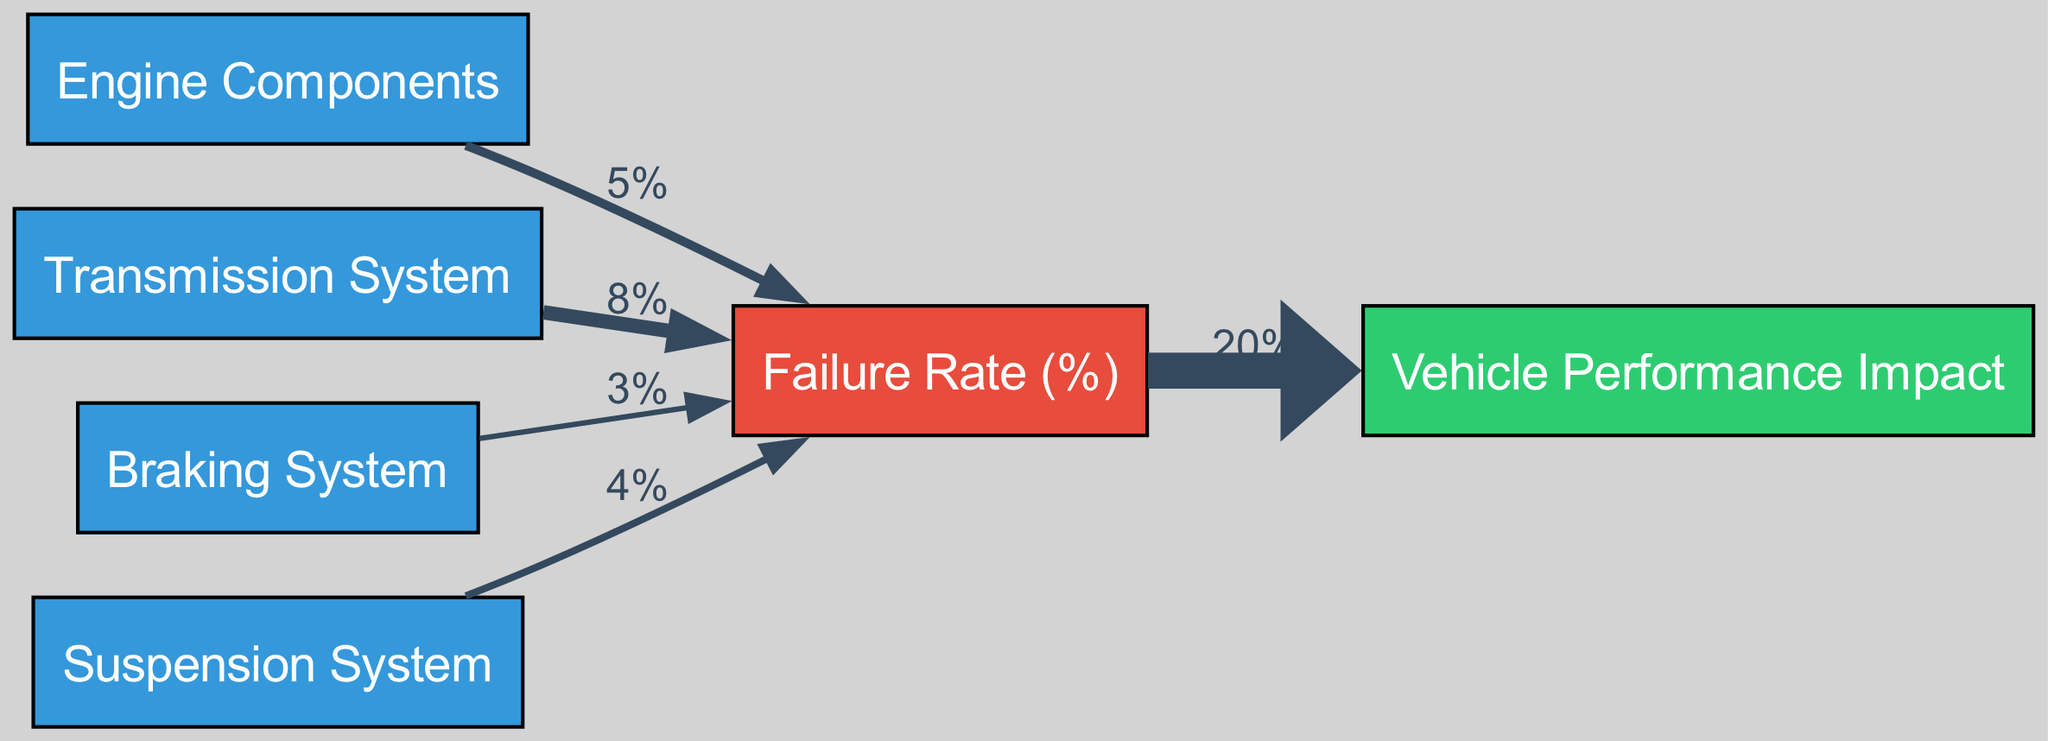What is the failure rate for Engine Components? By looking at the link between the "Engine Components" node and the "Failure Rate (%)" node, it shows a value of 5%.
Answer: 5% What is the failure rate for the Transmission System? The link connecting the "Transmission System" to "Failure Rate (%)" indicates a value of 8%.
Answer: 8% Which system has the lowest failure rate? Comparing the failure rates from each system, the Braking System shows the lowest value, which is 3%.
Answer: Braking System How many source nodes are there in the diagram? Counting the source nodes listed at the beginning (Engine Components, Transmission System, Braking System, Suspension System) gives a total of 4 source nodes.
Answer: 4 What impact does the overall failure rate have on vehicle performance? The diagram indicates that the "Failure Rate (%)" affects the "Vehicle Performance Impact" to a degree of 20%.
Answer: 20% Which component has the highest failure rate? Evaluating the failure rates, the Transmission System has the highest value of 8%.
Answer: Transmission System What is the value of the failure rate for the Suspension System? The link from the "Suspension System" to "Failure Rate (%)" shows a value of 4%.
Answer: 4% If the failure rates were to increase proportionately by 50%, what would the new failure rate for the Transmission System be? Increasing the Transmission System's failure rate of 8% by 50% yields a new value of 12% (8% + (0.5 * 8%)).
Answer: 12% What is the total impact on vehicle performance when considering all component failure rates? The diagram indicates that all components combined have a performance impact of 20% regardless of their individual failure rates.
Answer: 20% 